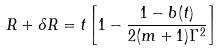Convert formula to latex. <formula><loc_0><loc_0><loc_500><loc_500>R + \delta R = t \left [ 1 - \frac { 1 - b ( t ) } { 2 ( m + 1 ) \Gamma ^ { 2 } } \right ]</formula> 